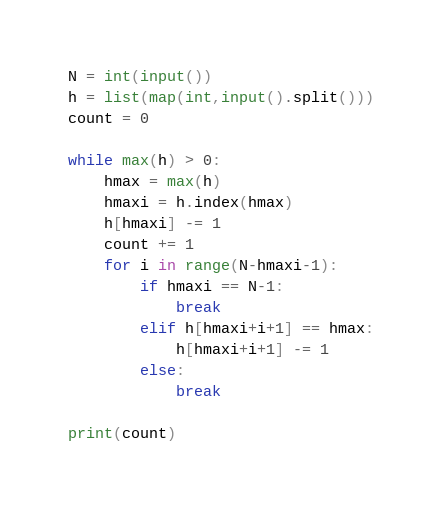<code> <loc_0><loc_0><loc_500><loc_500><_Python_>N = int(input())
h = list(map(int,input().split()))
count = 0

while max(h) > 0:
    hmax = max(h)
    hmaxi = h.index(hmax)
    h[hmaxi] -= 1
    count += 1
    for i in range(N-hmaxi-1):
        if hmaxi == N-1:
            break
        elif h[hmaxi+i+1] == hmax:
            h[hmaxi+i+1] -= 1
        else:
            break

print(count)</code> 